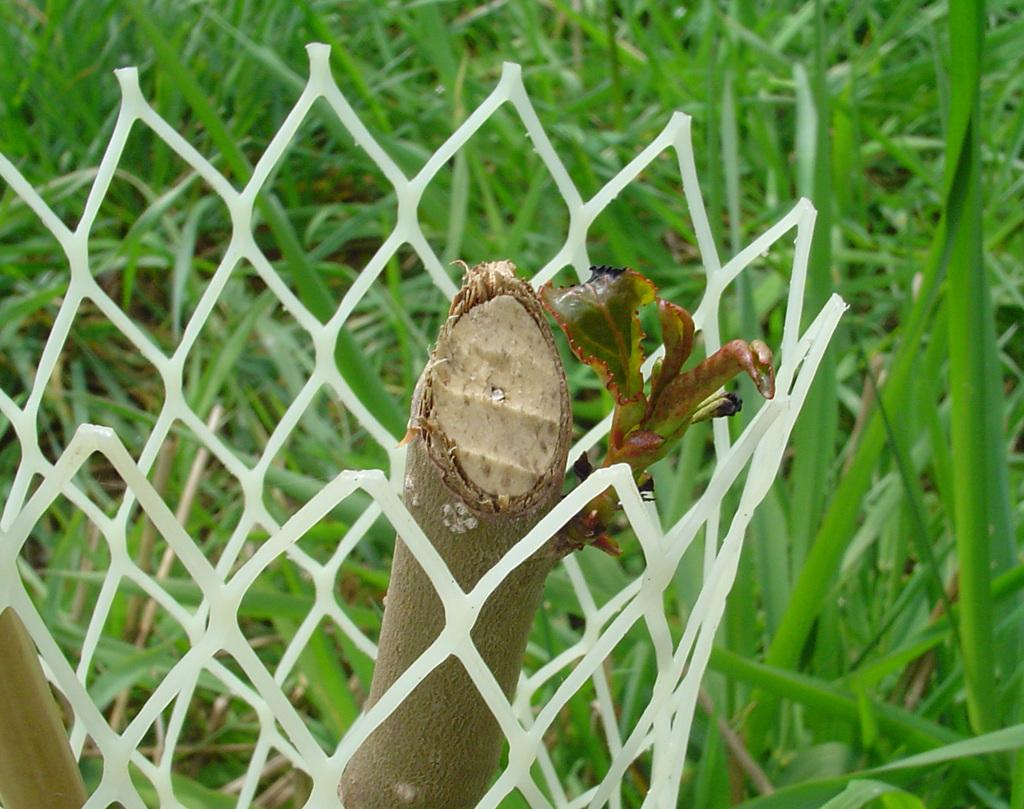What is located in the foreground of the image? There is a plant in the foreground of the image. What is surrounding the plant? There is fencing around the plant. What type of vegetation can be seen in the background of the image? There is grass visible in the background of the image. Can you hear the plant crying in the image? There is no indication in the image that the plant is making any sounds, including crying. 